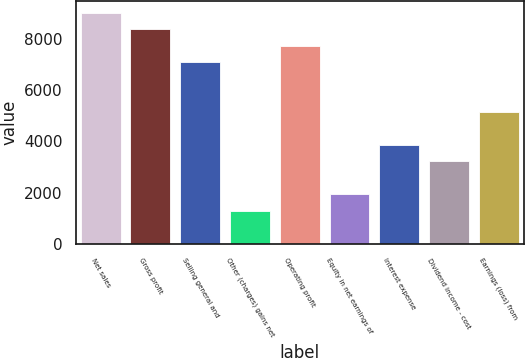Convert chart. <chart><loc_0><loc_0><loc_500><loc_500><bar_chart><fcel>Net sales<fcel>Gross profit<fcel>Selling general and<fcel>Other (charges) gains net<fcel>Operating profit<fcel>Equity in net earnings of<fcel>Interest expense<fcel>Dividend income - cost<fcel>Earnings (loss) from<nl><fcel>9018.84<fcel>8375.13<fcel>7087.71<fcel>1294.32<fcel>7731.42<fcel>1938.03<fcel>3869.16<fcel>3225.45<fcel>5156.58<nl></chart> 